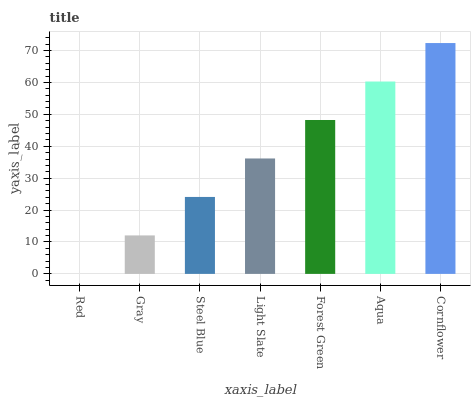Is Red the minimum?
Answer yes or no. Yes. Is Cornflower the maximum?
Answer yes or no. Yes. Is Gray the minimum?
Answer yes or no. No. Is Gray the maximum?
Answer yes or no. No. Is Gray greater than Red?
Answer yes or no. Yes. Is Red less than Gray?
Answer yes or no. Yes. Is Red greater than Gray?
Answer yes or no. No. Is Gray less than Red?
Answer yes or no. No. Is Light Slate the high median?
Answer yes or no. Yes. Is Light Slate the low median?
Answer yes or no. Yes. Is Aqua the high median?
Answer yes or no. No. Is Gray the low median?
Answer yes or no. No. 